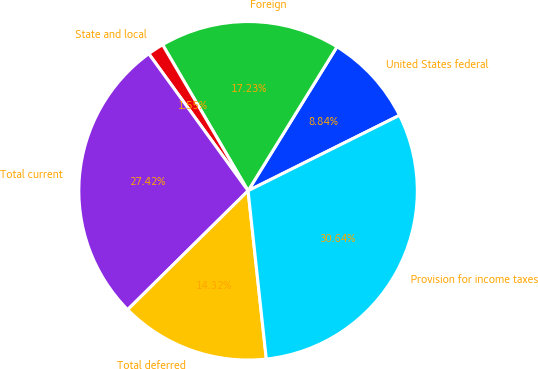Convert chart. <chart><loc_0><loc_0><loc_500><loc_500><pie_chart><fcel>United States federal<fcel>Foreign<fcel>State and local<fcel>Total current<fcel>Total deferred<fcel>Provision for income taxes<nl><fcel>8.84%<fcel>17.23%<fcel>1.55%<fcel>27.42%<fcel>14.32%<fcel>30.64%<nl></chart> 